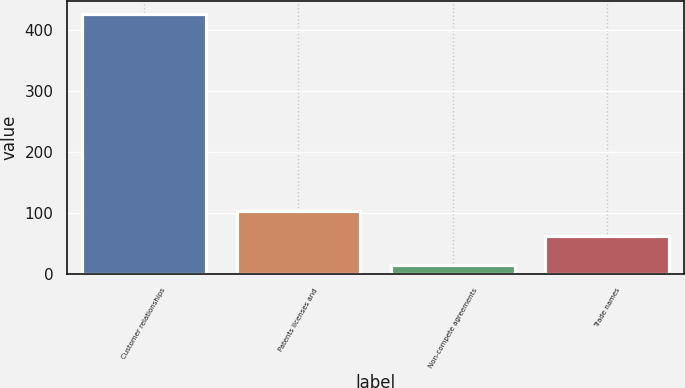Convert chart. <chart><loc_0><loc_0><loc_500><loc_500><bar_chart><fcel>Customer relationships<fcel>Patents licenses and<fcel>Non-compete agreements<fcel>Trade names<nl><fcel>426.8<fcel>102.5<fcel>14.8<fcel>61.3<nl></chart> 